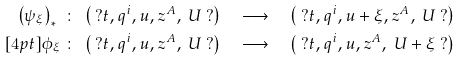Convert formula to latex. <formula><loc_0><loc_0><loc_500><loc_500>\left ( \psi _ { \xi } \right ) _ { * } \ & \colon \ \left ( \ ? t , q ^ { i } , u , z ^ { A } , \ U \ ? \right ) \quad \longrightarrow \quad \left ( \ ? t , q ^ { i } , u + \xi , z ^ { A } , \ U \ ? \right ) \\ [ 4 p t ] \phi _ { \xi } \ & \colon \ \left ( \ ? t , q ^ { i } , u , z ^ { A } , \ U \ ? \right ) \quad \longrightarrow \quad \left ( \ ? t , q ^ { i } , u , z ^ { A } , \ U + \xi \ ? \right )</formula> 